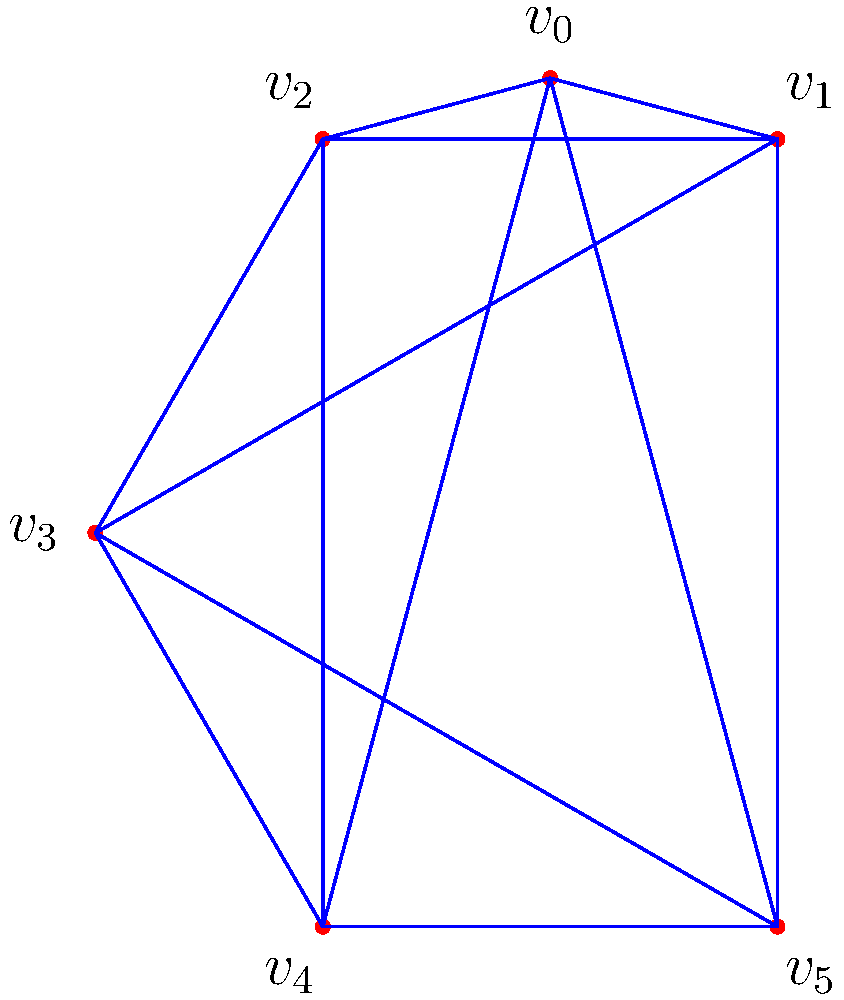The Cayley graph of the dihedral group $D_6$ (symmetries of a regular hexagon) is shown above. Each vertex represents an element of $D_6$, and edges represent group operations. If $v_0$ represents the identity element, and blue edges represent rotations by 60°, what is the order of the element represented by $v_3$? To determine the order of the element represented by $v_3$, we need to follow these steps:

1) In the dihedral group $D_6$, there are 12 elements: 6 rotations and 6 reflections.

2) The blue edges represent rotations by 60°. Since there are 6 vertices connected by blue edges in a cycle, these represent the 6 rotations of $D_6$.

3) Starting from $v_0$ (the identity element) and moving along blue edges:
   - $v_0$ to $v_1$: rotation by 60°
   - $v_1$ to $v_2$: another 60°, total 120°
   - $v_2$ to $v_3$: another 60°, total 180°

4) Therefore, $v_3$ represents a rotation by 180°, which is equivalent to a half-turn.

5) To find the order of this element, we need to determine how many times we need to apply this operation to get back to the identity:
   - Applying once: 180° rotation
   - Applying twice: 360° rotation = identity

6) Since we need to apply the operation twice to get back to the identity, the order of the element is 2.
Answer: 2 